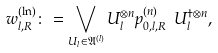<formula> <loc_0><loc_0><loc_500><loc_500>w _ { l , R } ^ { ( \ln ) } \colon = \bigvee _ { U _ { l } \in { \mathfrak A } ^ { ( l ) } } U _ { l } ^ { \otimes n } p _ { 0 , l , R } ^ { ( n ) } \ U _ { l } ^ { \dag \otimes n } ,</formula> 